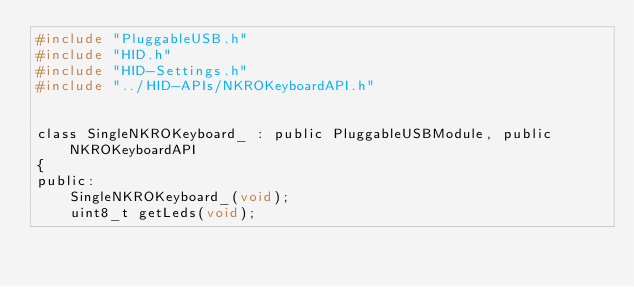<code> <loc_0><loc_0><loc_500><loc_500><_C_>#include "PluggableUSB.h"
#include "HID.h"
#include "HID-Settings.h"
#include "../HID-APIs/NKROKeyboardAPI.h"


class SingleNKROKeyboard_ : public PluggableUSBModule, public NKROKeyboardAPI
{
public:
    SingleNKROKeyboard_(void);
    uint8_t getLeds(void);</code> 